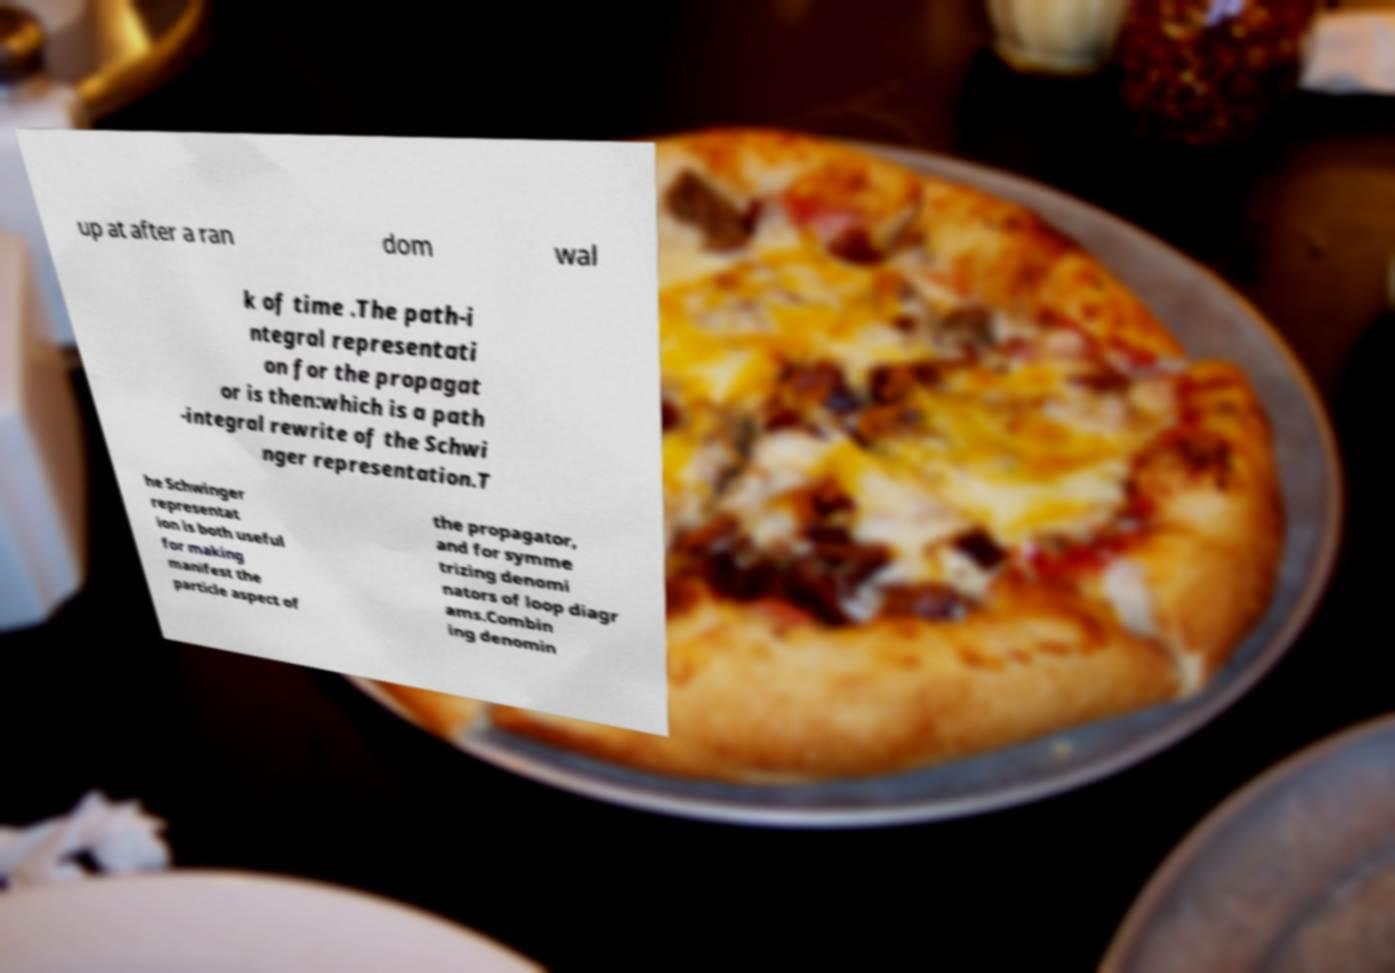Could you assist in decoding the text presented in this image and type it out clearly? up at after a ran dom wal k of time .The path-i ntegral representati on for the propagat or is then:which is a path -integral rewrite of the Schwi nger representation.T he Schwinger representat ion is both useful for making manifest the particle aspect of the propagator, and for symme trizing denomi nators of loop diagr ams.Combin ing denomin 